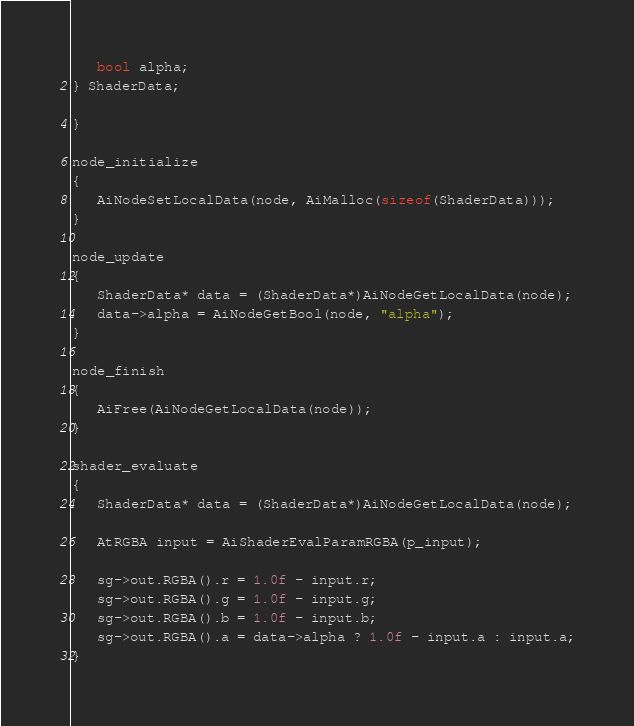Convert code to text. <code><loc_0><loc_0><loc_500><loc_500><_C++_>   bool alpha;
} ShaderData;

}

node_initialize 
{
   AiNodeSetLocalData(node, AiMalloc(sizeof(ShaderData)));
}

node_update 
{
   ShaderData* data = (ShaderData*)AiNodeGetLocalData(node);
   data->alpha = AiNodeGetBool(node, "alpha");
}

node_finish 
{
   AiFree(AiNodeGetLocalData(node));
}

shader_evaluate
{
   ShaderData* data = (ShaderData*)AiNodeGetLocalData(node);

   AtRGBA input = AiShaderEvalParamRGBA(p_input);

   sg->out.RGBA().r = 1.0f - input.r;
   sg->out.RGBA().g = 1.0f - input.g;
   sg->out.RGBA().b = 1.0f - input.b;
   sg->out.RGBA().a = data->alpha ? 1.0f - input.a : input.a;
}
</code> 